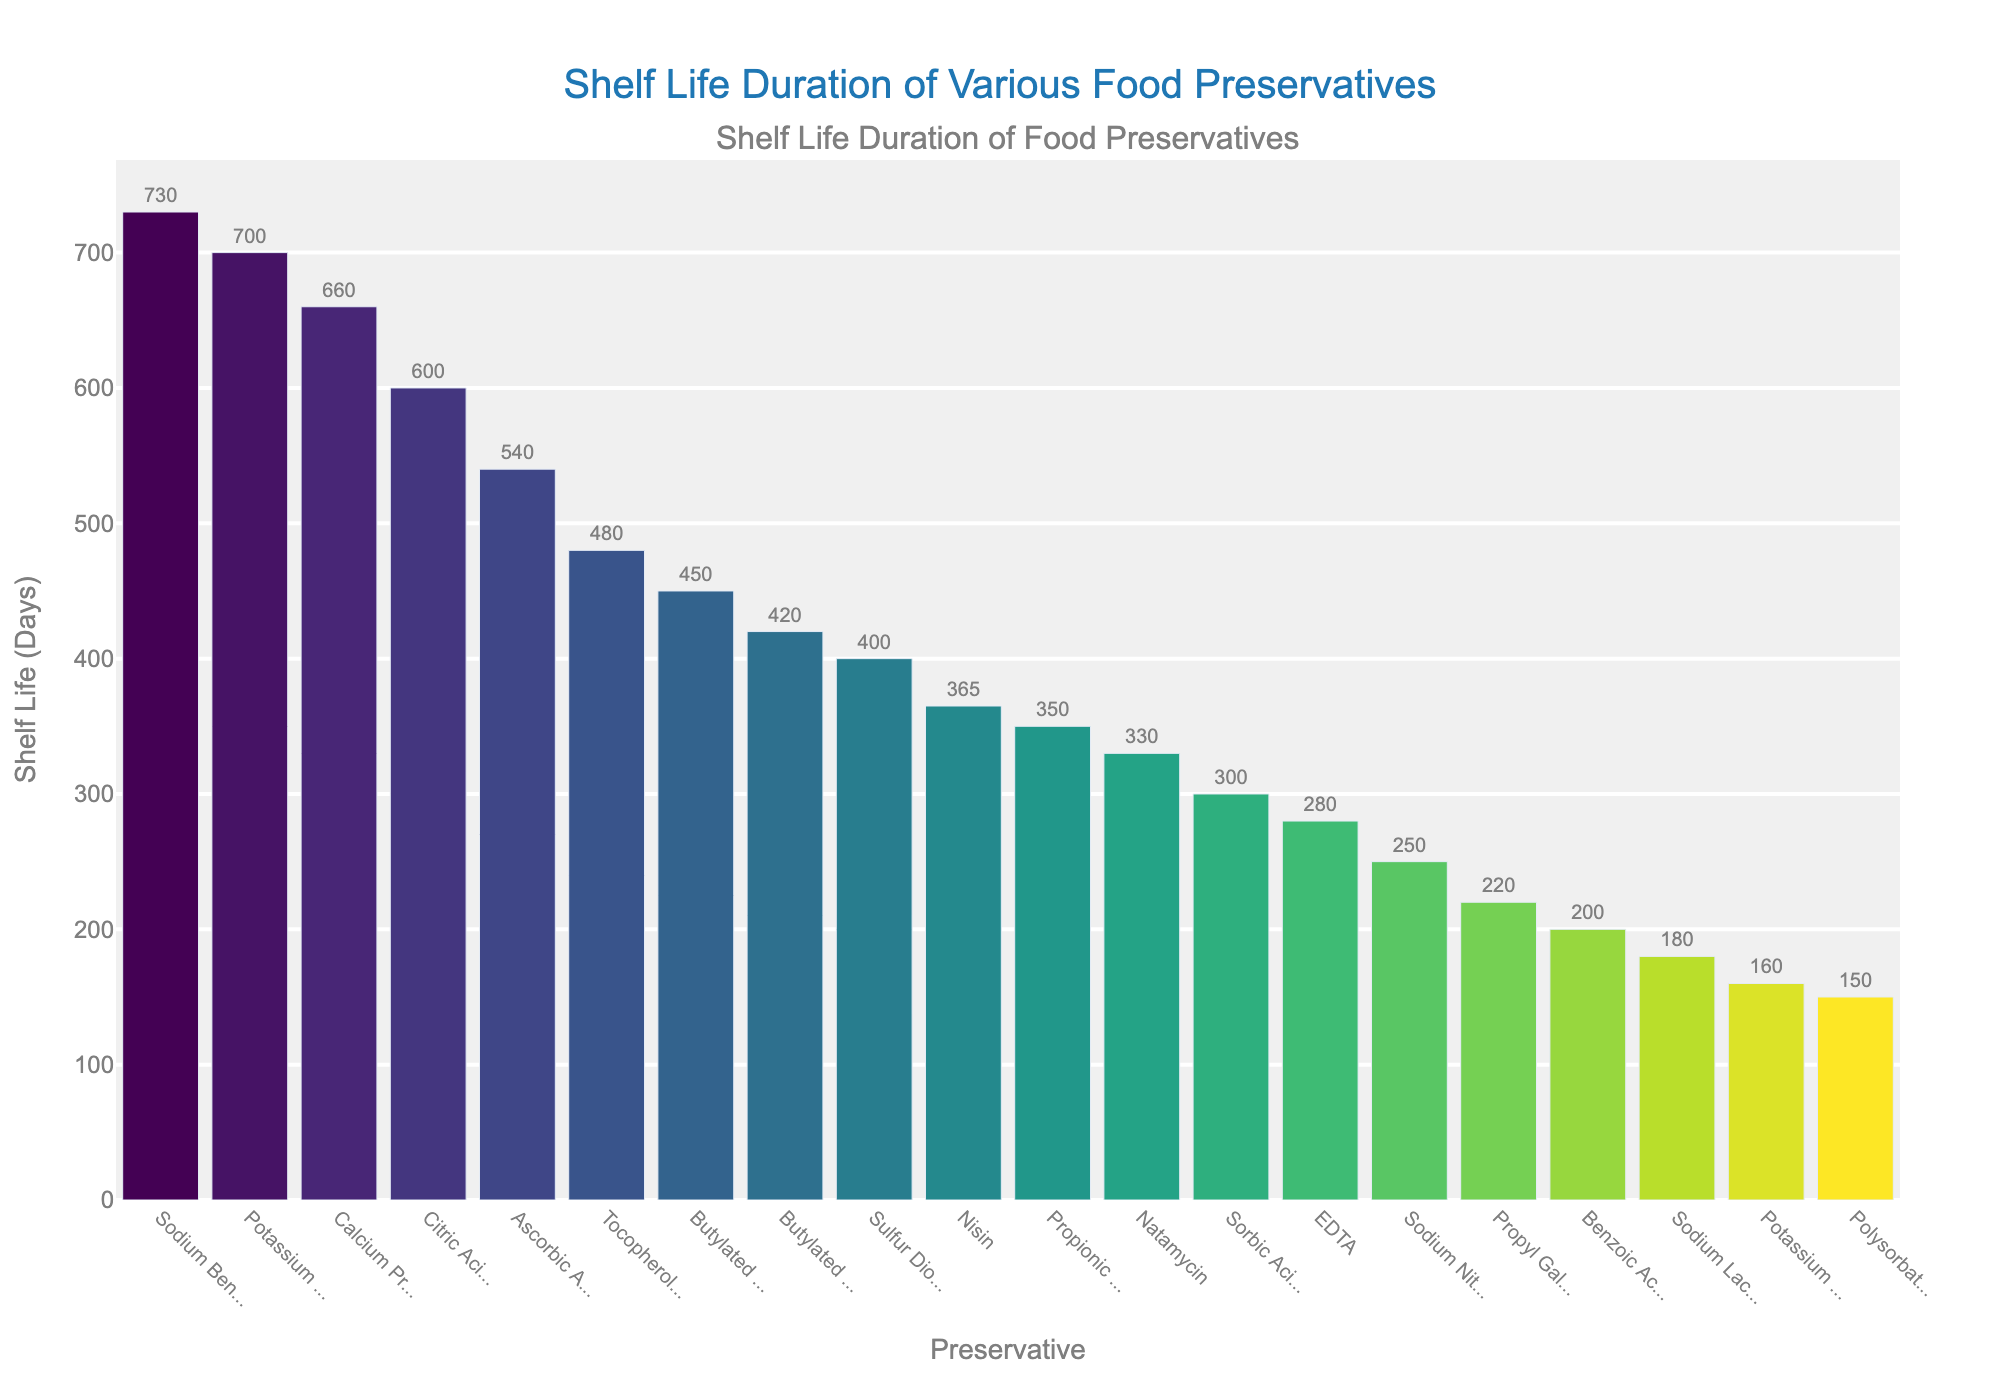What is the preservative with the longest shelf life? The bar representing Sodium Benzoate is the tallest in the graph, indicating the highest shelf life value. Therefore, Sodium Benzoate has the longest shelf life.
Answer: Sodium Benzoate Which two preservatives have the shortest shelf lives, and what are their durations? The two shortest bars in the graph represent Potassium Bisulfite and Polysorbate 80, indicating their shelf life durations are the lowest among all the preservatives. The durations can be read directly from the labels on the bars.
Answer: Potassium Bisulfite (160 days) and Polysorbate 80 (150 days) What is the average shelf life of Sodium Benzoate, Potassium Sorbate, and Calcium Propionate? Sum the shelf life values of Sodium Benzoate (730 days), Potassium Sorbate (700 days), and Calcium Propionate (660 days), and then divide by 3: (730 + 700 + 660) / 3 = 2090 / 3 = 696.67 days.
Answer: 696.67 days Compare the shelf lives of Citric Acid and Ascorbic Acid. Which one lasts longer and by how many days? Citric Acid has a shelf life of 600 days and Ascorbic Acid has a shelf life of 540 days. The difference between them is 600 - 540 = 60 days. Therefore, Citric Acid lasts longer by 60 days.
Answer: Citric Acid lasts longer by 60 days Which preservatives have a shelf life greater than 500 days? The bars that are visually higher than the 500-day mark correspond to Sodium Benzoate, Potassium Sorbate, Calcium Propionate, and Citric Acid. These preservatives all have shelf lives greater than 500 days.
Answer: Sodium Benzoate, Potassium Sorbate, Calcium Propionate, and Citric Acid How many preservatives have a shelf life between 300 and 400 days? The bars with labels showing shelf life values between 300 and 400 days are for Nisin, Propionic Acid, and Natamycin. Count these bars to get the answer.
Answer: Three preservatives What is the total shelf life duration if you combine Butylated Hydroxyanisole (BHA) and Butylated Hydroxytoluene (BHT)? Sum the shelf life values of Butylated Hydroxyanisole (BHA) (450 days) and Butylated Hydroxytoluene (BHT) (420 days): 450 + 420 = 870 days.
Answer: 870 days What is the median shelf life of the preservatives listed on the chart? First, list the shelf life values in ascending order and find the middle value. The median is the middle value when the numbers are arranged in order. To find the median: 
Sorted list: 150, 160, 180, 200, 220, 250, 280, 300, 330, 350, 365, 400, 420, 450, 480, 540, 600, 660, 700, 730
Median (middle value): (365 + 400) / 2 (since there are 20 values): (365 + 400)/2 = 382.5.
Answer: 382.5 days How does the color gradient help to identify preservatives with similar shelf lives? The color gradient in the chart ranges from light to dark hues. Preservatives with similar shelf lives are shown in similar shades of the same color, making it easier to visually group and compare them without looking at the exact values. For instance, preservatives with higher shelf lives are represented in darker shades, and those with lower shelf lives are in lighter shades.
Answer: Grouping by color 